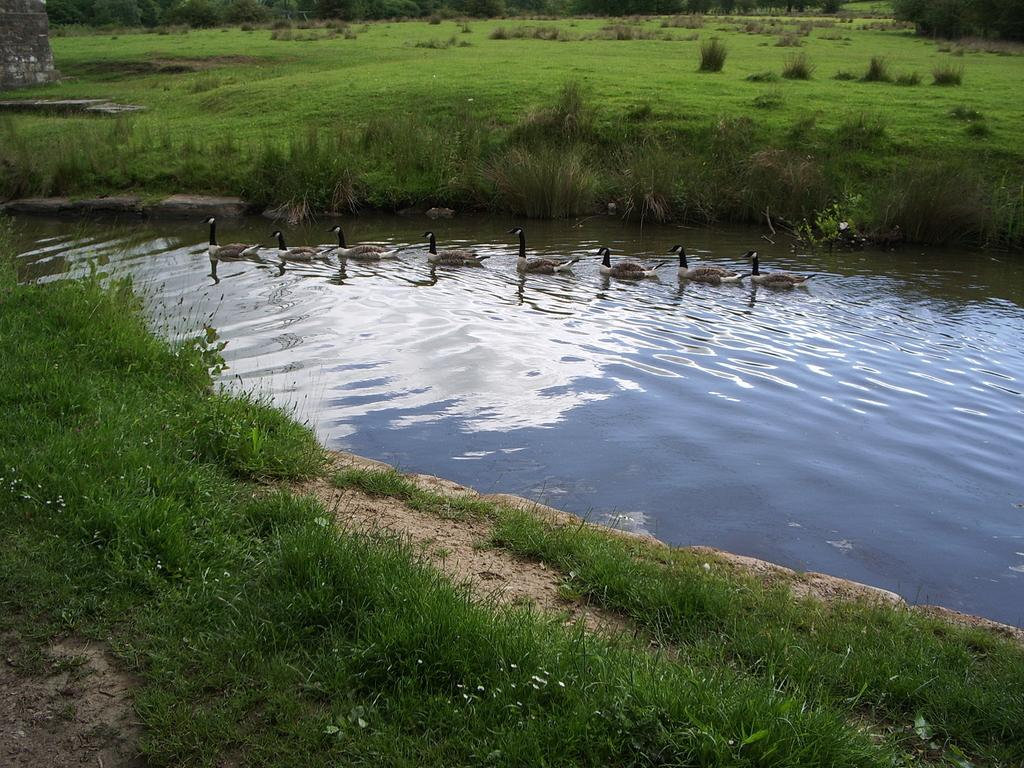What animals can be seen in the water at the center of the image? There are ducks in the water at the center of the image. What is floating on the surface of the water? There is grass visible on the surface of the water. What can be seen in the background of the image? There are trees in the background of the image. Where is the throne located in the image? There is no throne present in the image. What color is the noise in the image? There is no noise present in the image, and therefore no color can be assigned to it. 